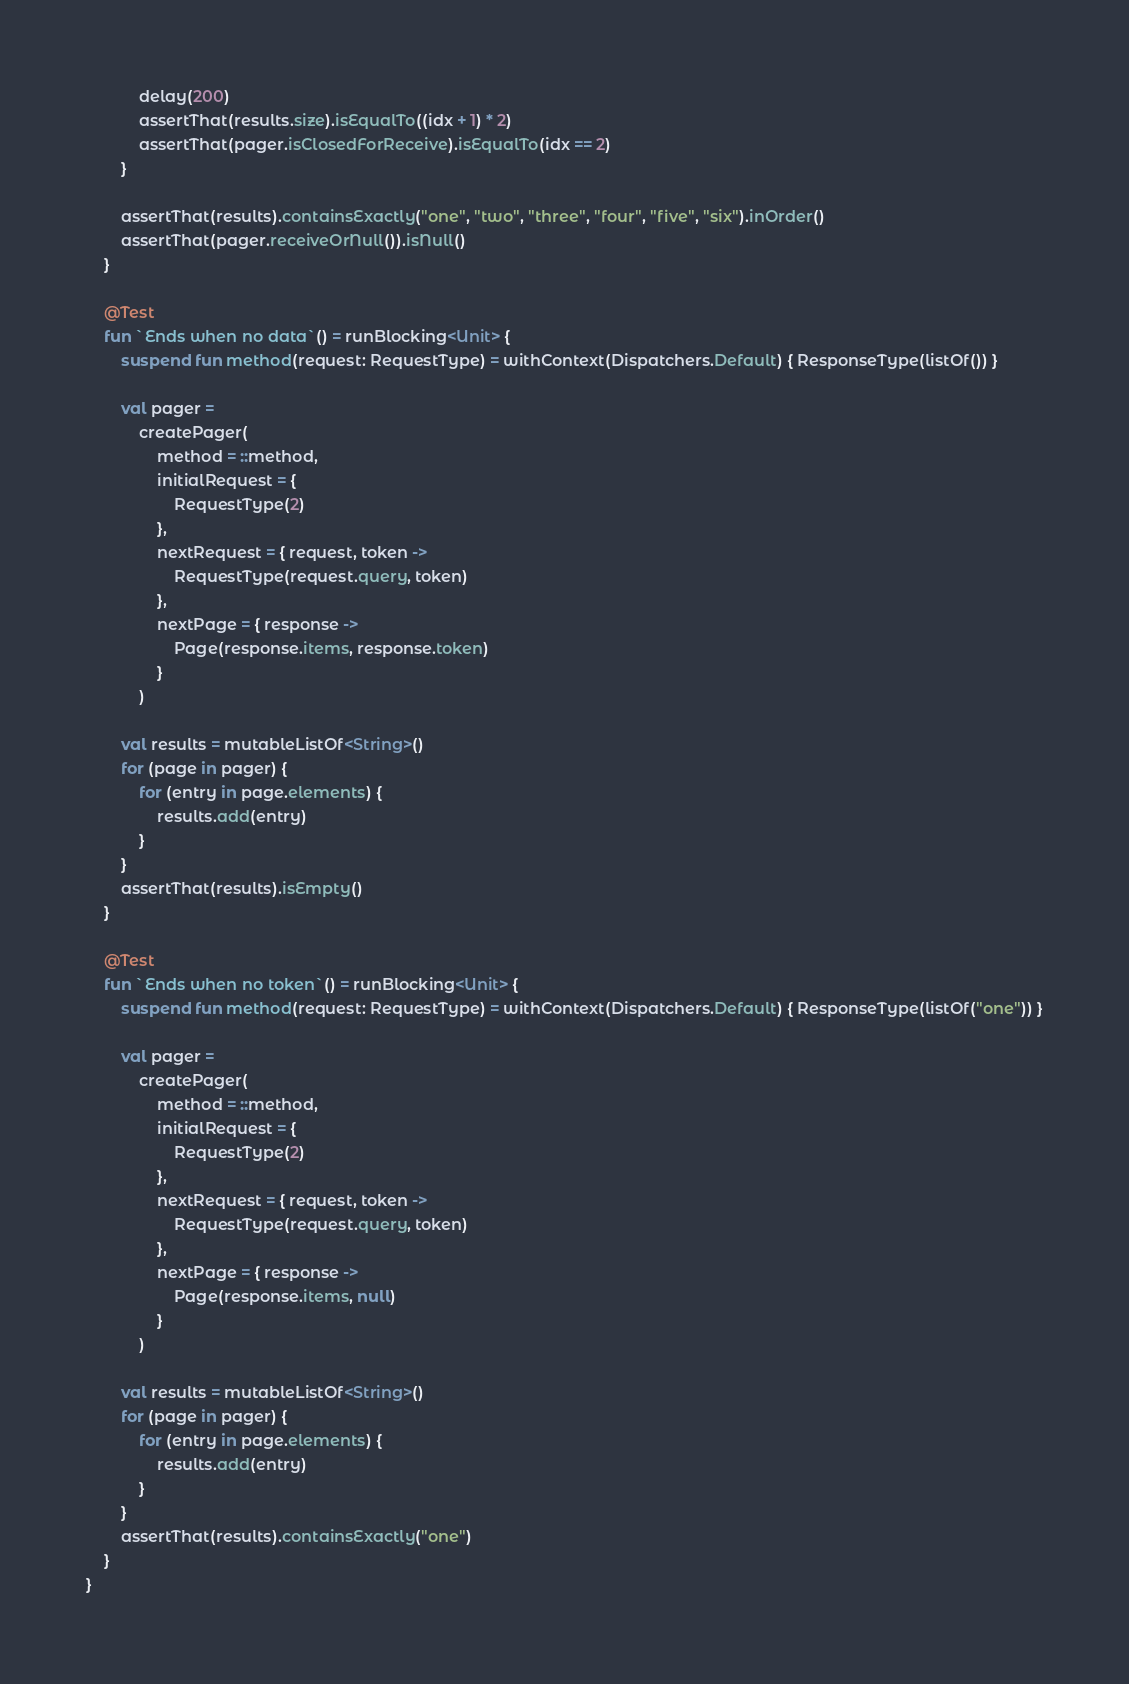<code> <loc_0><loc_0><loc_500><loc_500><_Kotlin_>
            delay(200)
            assertThat(results.size).isEqualTo((idx + 1) * 2)
            assertThat(pager.isClosedForReceive).isEqualTo(idx == 2)
        }

        assertThat(results).containsExactly("one", "two", "three", "four", "five", "six").inOrder()
        assertThat(pager.receiveOrNull()).isNull()
    }

    @Test
    fun `Ends when no data`() = runBlocking<Unit> {
        suspend fun method(request: RequestType) = withContext(Dispatchers.Default) { ResponseType(listOf()) }

        val pager =
            createPager(
                method = ::method,
                initialRequest = {
                    RequestType(2)
                },
                nextRequest = { request, token ->
                    RequestType(request.query, token)
                },
                nextPage = { response ->
                    Page(response.items, response.token)
                }
            )

        val results = mutableListOf<String>()
        for (page in pager) {
            for (entry in page.elements) {
                results.add(entry)
            }
        }
        assertThat(results).isEmpty()
    }

    @Test
    fun `Ends when no token`() = runBlocking<Unit> {
        suspend fun method(request: RequestType) = withContext(Dispatchers.Default) { ResponseType(listOf("one")) }

        val pager =
            createPager(
                method = ::method,
                initialRequest = {
                    RequestType(2)
                },
                nextRequest = { request, token ->
                    RequestType(request.query, token)
                },
                nextPage = { response ->
                    Page(response.items, null)
                }
            )

        val results = mutableListOf<String>()
        for (page in pager) {
            for (entry in page.elements) {
                results.add(entry)
            }
        }
        assertThat(results).containsExactly("one")
    }
}
</code> 